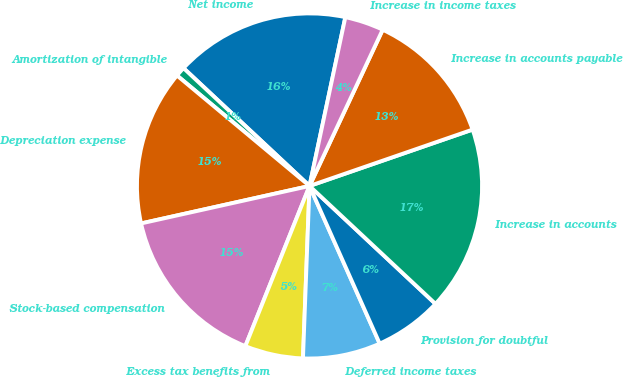Convert chart. <chart><loc_0><loc_0><loc_500><loc_500><pie_chart><fcel>Net income<fcel>Amortization of intangible<fcel>Depreciation expense<fcel>Stock-based compensation<fcel>Excess tax benefits from<fcel>Deferred income taxes<fcel>Provision for doubtful<fcel>Increase in accounts<fcel>Increase in accounts payable<fcel>Increase in income taxes<nl><fcel>16.36%<fcel>0.91%<fcel>14.54%<fcel>15.45%<fcel>5.46%<fcel>7.27%<fcel>6.36%<fcel>17.27%<fcel>12.73%<fcel>3.64%<nl></chart> 